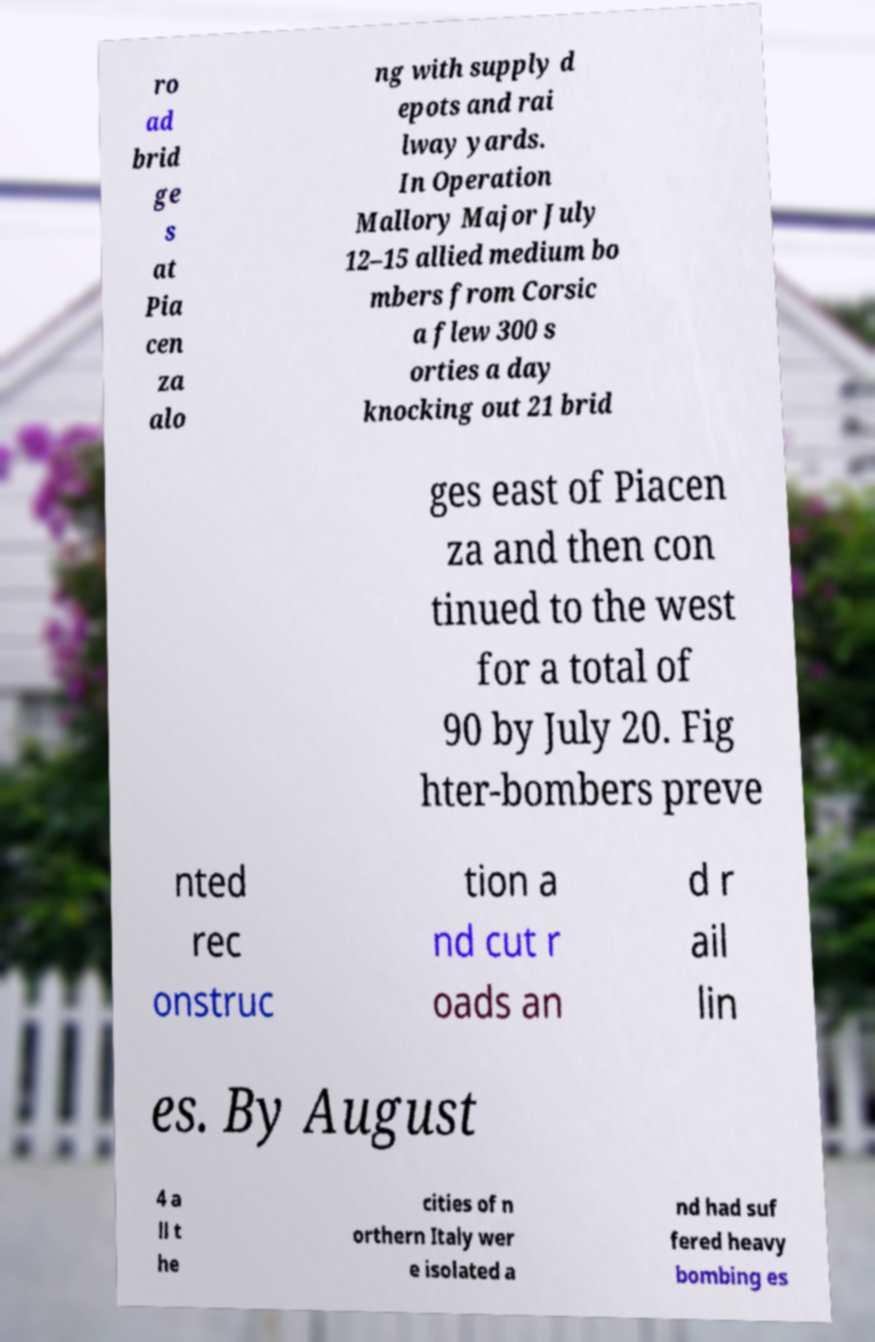Please identify and transcribe the text found in this image. ro ad brid ge s at Pia cen za alo ng with supply d epots and rai lway yards. In Operation Mallory Major July 12–15 allied medium bo mbers from Corsic a flew 300 s orties a day knocking out 21 brid ges east of Piacen za and then con tinued to the west for a total of 90 by July 20. Fig hter-bombers preve nted rec onstruc tion a nd cut r oads an d r ail lin es. By August 4 a ll t he cities of n orthern Italy wer e isolated a nd had suf fered heavy bombing es 